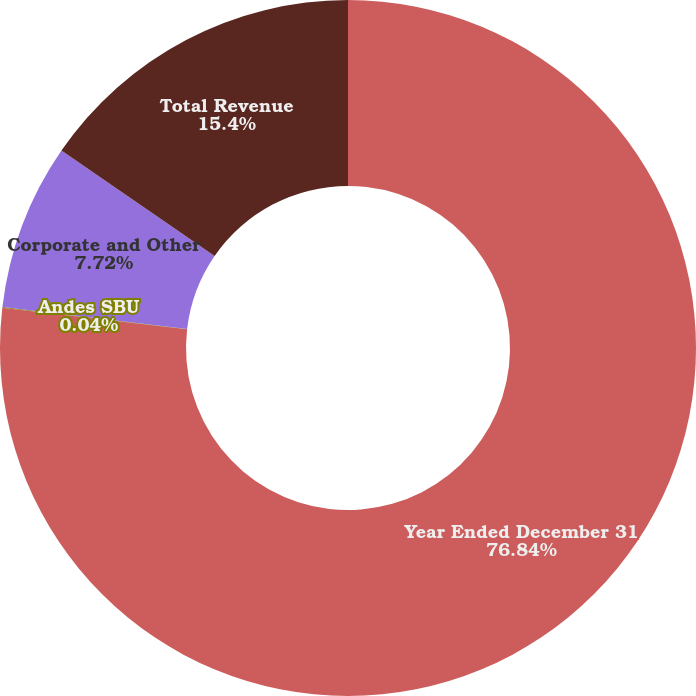Convert chart to OTSL. <chart><loc_0><loc_0><loc_500><loc_500><pie_chart><fcel>Year Ended December 31<fcel>Andes SBU<fcel>Corporate and Other<fcel>Total Revenue<nl><fcel>76.84%<fcel>0.04%<fcel>7.72%<fcel>15.4%<nl></chart> 